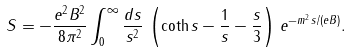Convert formula to latex. <formula><loc_0><loc_0><loc_500><loc_500>S = - \frac { e ^ { 2 } B ^ { 2 } } { 8 \pi ^ { 2 } } \int _ { 0 } ^ { \infty } \frac { d s } { s ^ { 2 } } \, \left ( \coth s - \frac { 1 } { s } - \frac { s } { 3 } \right ) \, e ^ { - m ^ { 2 } s / ( e B ) } .</formula> 